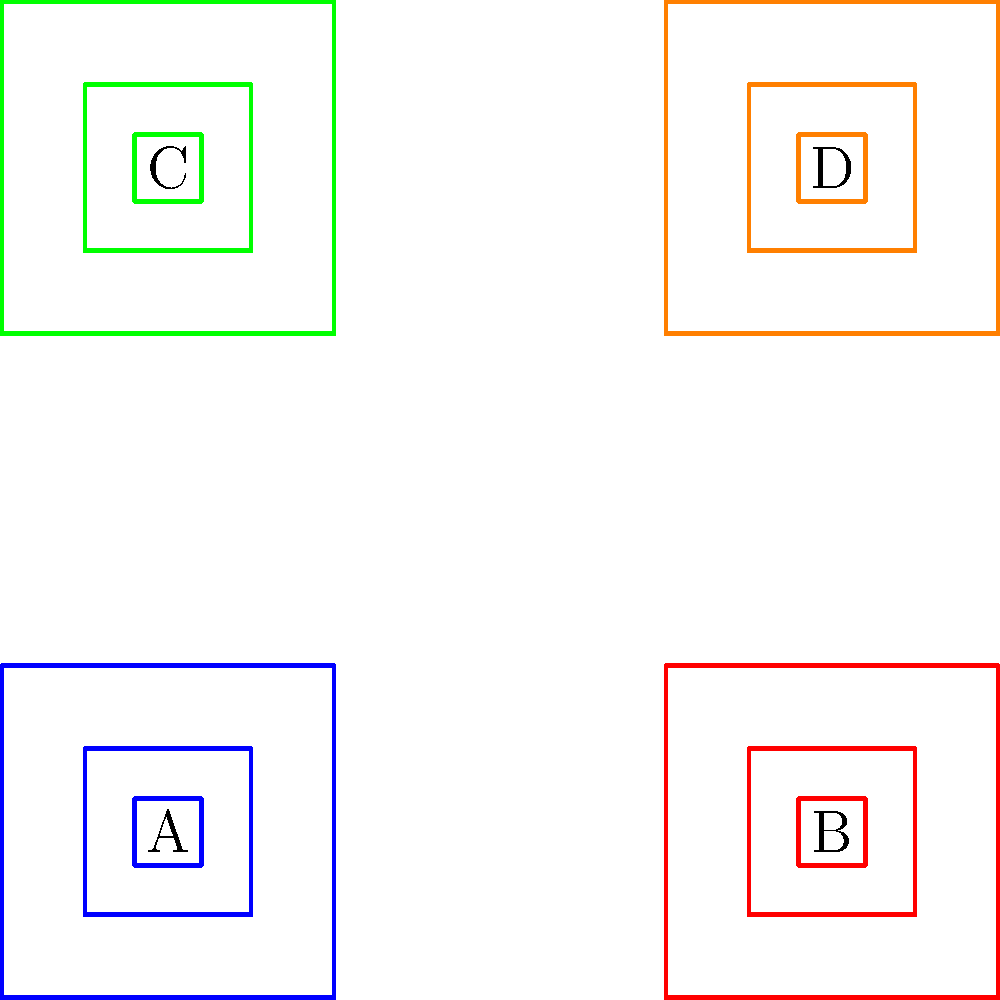The image above shows a simplified representation of a traditional Andean textile pattern. What is the order of the symmetry group for this pattern, considering rotations and reflections? To determine the order of the symmetry group, we need to identify all the symmetry operations that leave the pattern unchanged. Let's analyze step-by-step:

1. Rotational symmetries:
   - 360° rotation (identity): Always present
   - 180° rotation around the center: The pattern remains unchanged
   
2. Reflection symmetries:
   - Horizontal reflection through the middle: Swaps A with C, and B with D
   - Vertical reflection through the middle: Swaps A with B, and C with D
   - Diagonal reflection (top-left to bottom-right): Swaps B with C
   - Diagonal reflection (top-right to bottom-left): Swaps A with D

3. Counting the symmetries:
   - 2 rotational symmetries (0° and 180°)
   - 4 reflection symmetries (horizontal, vertical, and two diagonals)

4. Total number of symmetries:
   $2 + 4 = 6$

Therefore, the order of the symmetry group for this pattern is 6. This group is isomorphic to the dihedral group $D_4$, which is the symmetry group of a square.
Answer: 6 